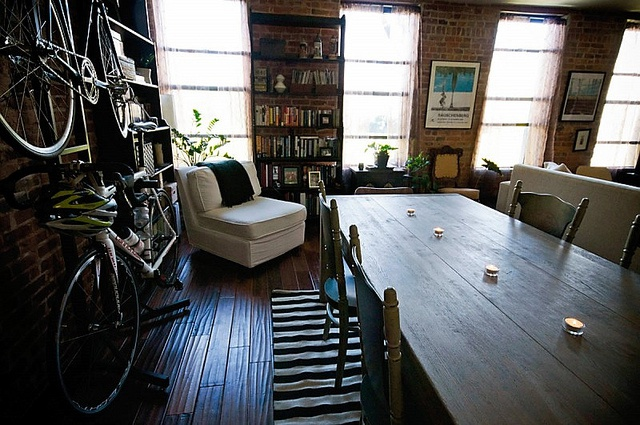Describe the objects in this image and their specific colors. I can see dining table in black, gray, darkgray, and lightgray tones, bicycle in black, gray, darkgray, and darkgreen tones, bicycle in black, gray, lightgray, and darkgray tones, book in black, white, and gray tones, and chair in black, gray, and darkgray tones in this image. 